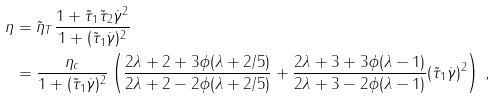Convert formula to latex. <formula><loc_0><loc_0><loc_500><loc_500>\eta & = \tilde { \eta } _ { T } \frac { 1 + \tilde { \tau } _ { 1 } \tilde { \tau } _ { 2 } \dot { \gamma } ^ { 2 } } { 1 + ( \tilde { \tau } _ { 1 } \dot { \gamma } ) ^ { 2 } } \\ & = \frac { \eta _ { c } } { 1 + ( \tilde { \tau } _ { 1 } \dot { \gamma } ) ^ { 2 } } \left ( \frac { 2 \lambda + 2 + 3 \phi ( \lambda + 2 / 5 ) } { 2 \lambda + 2 - 2 \phi ( \lambda + 2 / 5 ) } + \frac { 2 \lambda + 3 + 3 \phi ( \lambda - 1 ) } { 2 \lambda + 3 - 2 \phi ( \lambda - 1 ) } ( \tilde { \tau } _ { 1 } \dot { \gamma } ) ^ { 2 } \right ) \, ,</formula> 